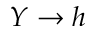Convert formula to latex. <formula><loc_0><loc_0><loc_500><loc_500>Y \rightarrow h</formula> 